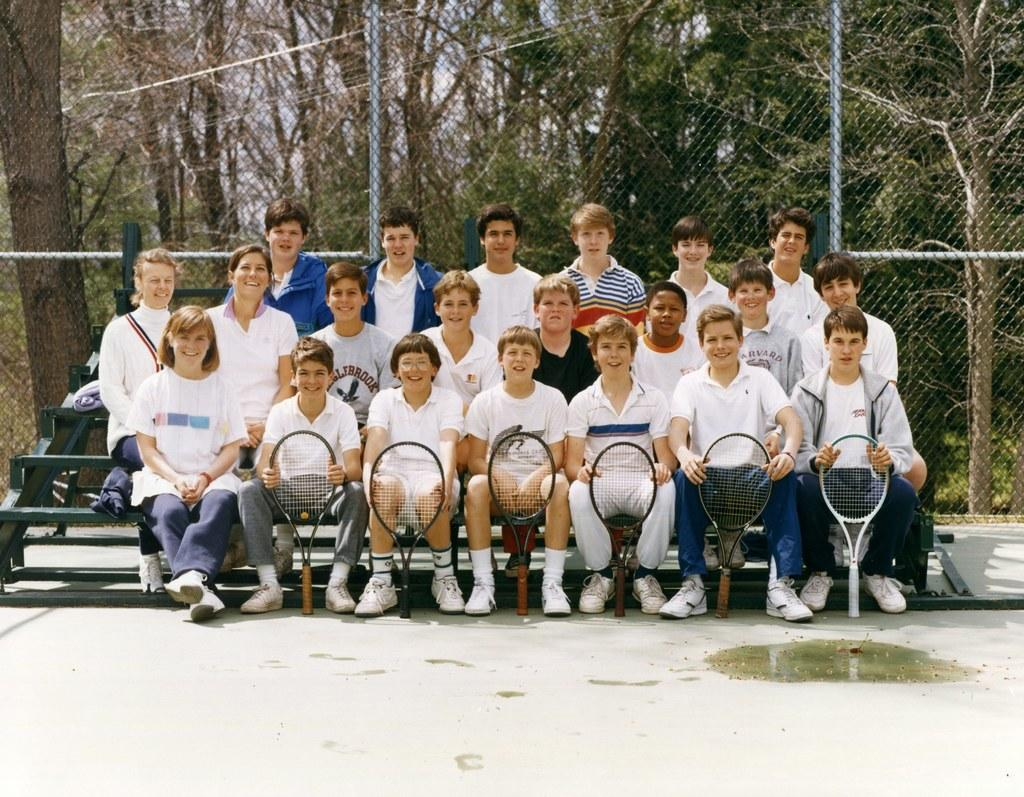What are the people in the image doing? There are people standing and sitting in the image. What are the people sitting holding? The people sitting are holding bats. What can be seen in the background of the image? There is a fence, trees, and the sky visible in the background of the image. What type of suggestion can be seen written on the flag in the image? There is no flag present in the image, so it is not possible to determine if there is any suggestion written on it. 